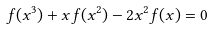<formula> <loc_0><loc_0><loc_500><loc_500>f ( x ^ { 3 } ) + x f ( x ^ { 2 } ) - 2 x ^ { 2 } f ( x ) = 0</formula> 